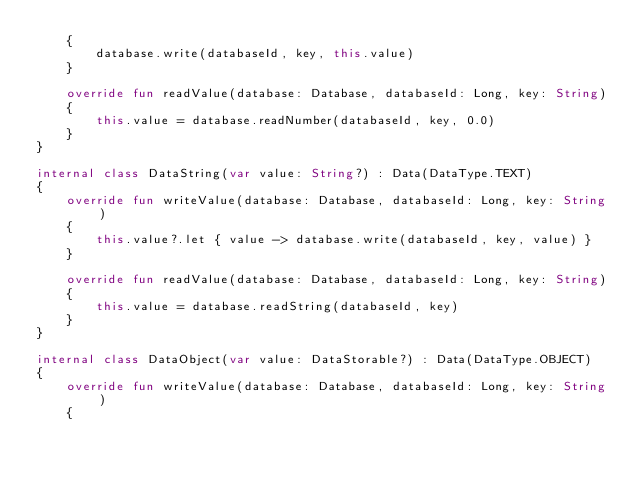<code> <loc_0><loc_0><loc_500><loc_500><_Kotlin_>    {
        database.write(databaseId, key, this.value)
    }

    override fun readValue(database: Database, databaseId: Long, key: String)
    {
        this.value = database.readNumber(databaseId, key, 0.0)
    }
}

internal class DataString(var value: String?) : Data(DataType.TEXT)
{
    override fun writeValue(database: Database, databaseId: Long, key: String)
    {
        this.value?.let { value -> database.write(databaseId, key, value) }
    }

    override fun readValue(database: Database, databaseId: Long, key: String)
    {
        this.value = database.readString(databaseId, key)
    }
}

internal class DataObject(var value: DataStorable?) : Data(DataType.OBJECT)
{
    override fun writeValue(database: Database, databaseId: Long, key: String)
    {</code> 